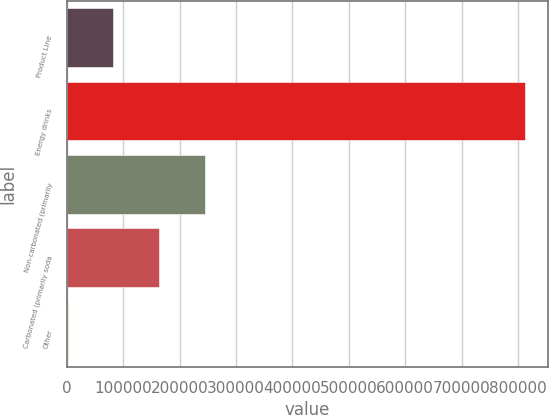Convert chart. <chart><loc_0><loc_0><loc_500><loc_500><bar_chart><fcel>Product Line<fcel>Energy drinks<fcel>Non-carbonated (primarily<fcel>Carbonated (primarily soda<fcel>Other<nl><fcel>82885.3<fcel>811609<fcel>244824<fcel>163855<fcel>1916<nl></chart> 